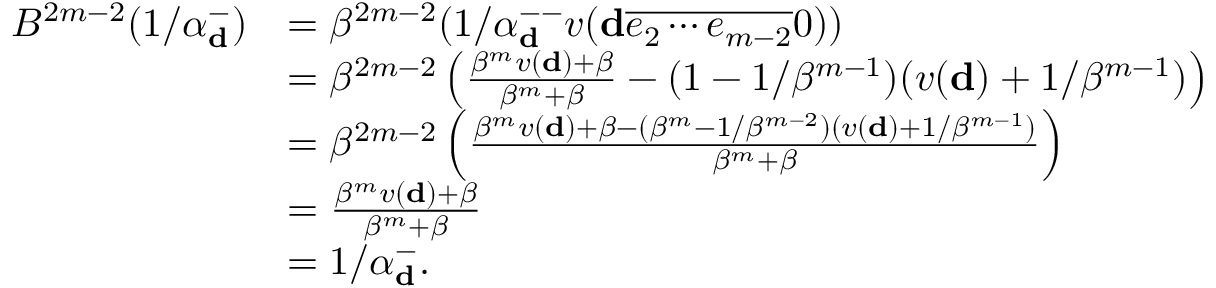Convert formula to latex. <formula><loc_0><loc_0><loc_500><loc_500>\begin{array} { r l } { B ^ { 2 m - 2 } ( 1 / \alpha _ { \mathbf d } ^ { - } ) } & { = \beta ^ { 2 m - 2 } ( 1 / \alpha _ { \mathbf d } ^ { - - } v ( \mathbf d \overline { { e _ { 2 } \cdots e _ { m - 2 } } } 0 ) ) } \\ & { = \beta ^ { 2 m - 2 } \left ( \frac { \beta ^ { m } v ( \mathbf d ) + \beta } { \beta ^ { m } + \beta } - ( 1 - 1 / \beta ^ { m - 1 } ) ( v ( \mathbf d ) + 1 / \beta ^ { m - 1 } ) \right ) } \\ & { = \beta ^ { 2 m - 2 } \left ( \frac { \beta ^ { m } v ( \mathbf d ) + \beta - ( \beta ^ { m } - 1 / \beta ^ { m - 2 } ) ( v ( \mathbf d ) + 1 / \beta ^ { m - 1 } ) } { \beta ^ { m } + \beta } \right ) } \\ & { = \frac { \beta ^ { m } v ( \mathbf d ) + \beta } { \beta ^ { m } + \beta } } \\ & { = 1 / \alpha _ { \mathbf d } ^ { - } . } \end{array}</formula> 